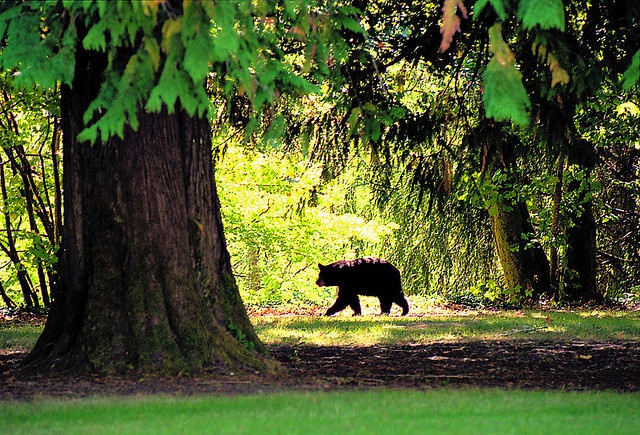Describe the objects in this image and their specific colors. I can see a bear in black, ivory, khaki, and maroon tones in this image. 